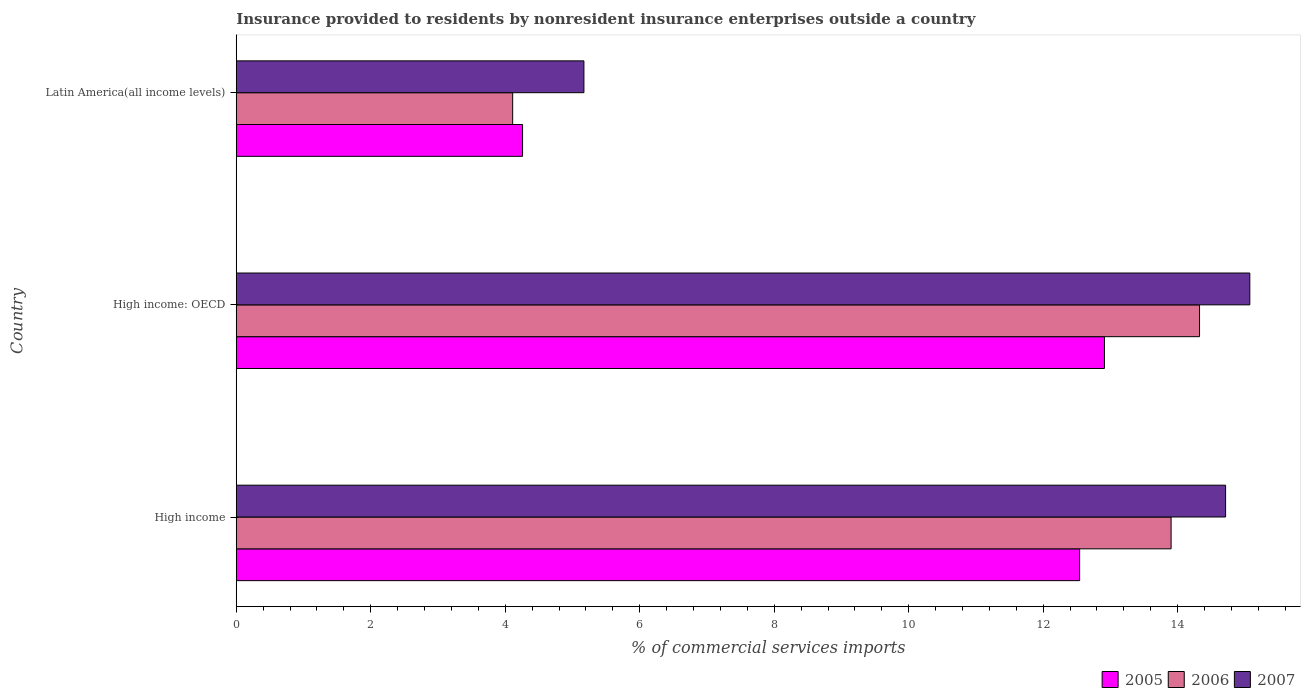How many different coloured bars are there?
Offer a very short reply. 3. How many groups of bars are there?
Your answer should be compact. 3. Are the number of bars on each tick of the Y-axis equal?
Keep it short and to the point. Yes. How many bars are there on the 2nd tick from the bottom?
Your answer should be very brief. 3. What is the label of the 2nd group of bars from the top?
Keep it short and to the point. High income: OECD. In how many cases, is the number of bars for a given country not equal to the number of legend labels?
Provide a succinct answer. 0. What is the Insurance provided to residents in 2006 in Latin America(all income levels)?
Your response must be concise. 4.11. Across all countries, what is the maximum Insurance provided to residents in 2006?
Provide a short and direct response. 14.33. Across all countries, what is the minimum Insurance provided to residents in 2005?
Your response must be concise. 4.26. In which country was the Insurance provided to residents in 2007 maximum?
Provide a succinct answer. High income: OECD. In which country was the Insurance provided to residents in 2005 minimum?
Make the answer very short. Latin America(all income levels). What is the total Insurance provided to residents in 2005 in the graph?
Your answer should be compact. 29.71. What is the difference between the Insurance provided to residents in 2006 in High income and that in High income: OECD?
Keep it short and to the point. -0.42. What is the difference between the Insurance provided to residents in 2006 in High income and the Insurance provided to residents in 2005 in Latin America(all income levels)?
Offer a terse response. 9.64. What is the average Insurance provided to residents in 2007 per country?
Your answer should be very brief. 11.65. What is the difference between the Insurance provided to residents in 2006 and Insurance provided to residents in 2007 in High income: OECD?
Make the answer very short. -0.75. What is the ratio of the Insurance provided to residents in 2006 in High income to that in High income: OECD?
Offer a terse response. 0.97. Is the Insurance provided to residents in 2007 in High income less than that in Latin America(all income levels)?
Keep it short and to the point. No. Is the difference between the Insurance provided to residents in 2006 in High income and High income: OECD greater than the difference between the Insurance provided to residents in 2007 in High income and High income: OECD?
Keep it short and to the point. No. What is the difference between the highest and the second highest Insurance provided to residents in 2006?
Your response must be concise. 0.42. What is the difference between the highest and the lowest Insurance provided to residents in 2006?
Give a very brief answer. 10.21. Is the sum of the Insurance provided to residents in 2006 in High income and Latin America(all income levels) greater than the maximum Insurance provided to residents in 2005 across all countries?
Your answer should be very brief. Yes. How many bars are there?
Your answer should be very brief. 9. What is the title of the graph?
Provide a short and direct response. Insurance provided to residents by nonresident insurance enterprises outside a country. Does "1986" appear as one of the legend labels in the graph?
Provide a succinct answer. No. What is the label or title of the X-axis?
Offer a very short reply. % of commercial services imports. What is the % of commercial services imports in 2005 in High income?
Provide a short and direct response. 12.54. What is the % of commercial services imports of 2006 in High income?
Your answer should be very brief. 13.9. What is the % of commercial services imports of 2007 in High income?
Give a very brief answer. 14.71. What is the % of commercial services imports of 2005 in High income: OECD?
Give a very brief answer. 12.91. What is the % of commercial services imports in 2006 in High income: OECD?
Offer a terse response. 14.33. What is the % of commercial services imports of 2007 in High income: OECD?
Offer a very short reply. 15.07. What is the % of commercial services imports in 2005 in Latin America(all income levels)?
Give a very brief answer. 4.26. What is the % of commercial services imports in 2006 in Latin America(all income levels)?
Offer a terse response. 4.11. What is the % of commercial services imports of 2007 in Latin America(all income levels)?
Provide a succinct answer. 5.17. Across all countries, what is the maximum % of commercial services imports of 2005?
Your response must be concise. 12.91. Across all countries, what is the maximum % of commercial services imports in 2006?
Give a very brief answer. 14.33. Across all countries, what is the maximum % of commercial services imports in 2007?
Give a very brief answer. 15.07. Across all countries, what is the minimum % of commercial services imports of 2005?
Your answer should be compact. 4.26. Across all countries, what is the minimum % of commercial services imports of 2006?
Keep it short and to the point. 4.11. Across all countries, what is the minimum % of commercial services imports in 2007?
Make the answer very short. 5.17. What is the total % of commercial services imports in 2005 in the graph?
Ensure brevity in your answer.  29.71. What is the total % of commercial services imports of 2006 in the graph?
Make the answer very short. 32.34. What is the total % of commercial services imports of 2007 in the graph?
Keep it short and to the point. 34.96. What is the difference between the % of commercial services imports in 2005 in High income and that in High income: OECD?
Offer a very short reply. -0.37. What is the difference between the % of commercial services imports in 2006 in High income and that in High income: OECD?
Offer a terse response. -0.42. What is the difference between the % of commercial services imports in 2007 in High income and that in High income: OECD?
Provide a short and direct response. -0.36. What is the difference between the % of commercial services imports in 2005 in High income and that in Latin America(all income levels)?
Give a very brief answer. 8.28. What is the difference between the % of commercial services imports in 2006 in High income and that in Latin America(all income levels)?
Your response must be concise. 9.79. What is the difference between the % of commercial services imports of 2007 in High income and that in Latin America(all income levels)?
Offer a terse response. 9.54. What is the difference between the % of commercial services imports in 2005 in High income: OECD and that in Latin America(all income levels)?
Provide a short and direct response. 8.65. What is the difference between the % of commercial services imports of 2006 in High income: OECD and that in Latin America(all income levels)?
Ensure brevity in your answer.  10.21. What is the difference between the % of commercial services imports in 2007 in High income: OECD and that in Latin America(all income levels)?
Keep it short and to the point. 9.9. What is the difference between the % of commercial services imports in 2005 in High income and the % of commercial services imports in 2006 in High income: OECD?
Keep it short and to the point. -1.78. What is the difference between the % of commercial services imports in 2005 in High income and the % of commercial services imports in 2007 in High income: OECD?
Ensure brevity in your answer.  -2.53. What is the difference between the % of commercial services imports of 2006 in High income and the % of commercial services imports of 2007 in High income: OECD?
Make the answer very short. -1.17. What is the difference between the % of commercial services imports of 2005 in High income and the % of commercial services imports of 2006 in Latin America(all income levels)?
Ensure brevity in your answer.  8.43. What is the difference between the % of commercial services imports of 2005 in High income and the % of commercial services imports of 2007 in Latin America(all income levels)?
Provide a short and direct response. 7.37. What is the difference between the % of commercial services imports in 2006 in High income and the % of commercial services imports in 2007 in Latin America(all income levels)?
Give a very brief answer. 8.73. What is the difference between the % of commercial services imports in 2005 in High income: OECD and the % of commercial services imports in 2006 in Latin America(all income levels)?
Keep it short and to the point. 8.8. What is the difference between the % of commercial services imports in 2005 in High income: OECD and the % of commercial services imports in 2007 in Latin America(all income levels)?
Give a very brief answer. 7.74. What is the difference between the % of commercial services imports of 2006 in High income: OECD and the % of commercial services imports of 2007 in Latin America(all income levels)?
Your answer should be compact. 9.15. What is the average % of commercial services imports in 2005 per country?
Your answer should be compact. 9.9. What is the average % of commercial services imports of 2006 per country?
Your response must be concise. 10.78. What is the average % of commercial services imports in 2007 per country?
Provide a short and direct response. 11.65. What is the difference between the % of commercial services imports of 2005 and % of commercial services imports of 2006 in High income?
Provide a short and direct response. -1.36. What is the difference between the % of commercial services imports in 2005 and % of commercial services imports in 2007 in High income?
Your answer should be very brief. -2.17. What is the difference between the % of commercial services imports in 2006 and % of commercial services imports in 2007 in High income?
Provide a succinct answer. -0.81. What is the difference between the % of commercial services imports in 2005 and % of commercial services imports in 2006 in High income: OECD?
Offer a terse response. -1.41. What is the difference between the % of commercial services imports of 2005 and % of commercial services imports of 2007 in High income: OECD?
Ensure brevity in your answer.  -2.16. What is the difference between the % of commercial services imports in 2006 and % of commercial services imports in 2007 in High income: OECD?
Provide a short and direct response. -0.75. What is the difference between the % of commercial services imports of 2005 and % of commercial services imports of 2006 in Latin America(all income levels)?
Your response must be concise. 0.15. What is the difference between the % of commercial services imports in 2005 and % of commercial services imports in 2007 in Latin America(all income levels)?
Keep it short and to the point. -0.91. What is the difference between the % of commercial services imports in 2006 and % of commercial services imports in 2007 in Latin America(all income levels)?
Offer a very short reply. -1.06. What is the ratio of the % of commercial services imports of 2005 in High income to that in High income: OECD?
Provide a short and direct response. 0.97. What is the ratio of the % of commercial services imports of 2006 in High income to that in High income: OECD?
Your response must be concise. 0.97. What is the ratio of the % of commercial services imports in 2007 in High income to that in High income: OECD?
Keep it short and to the point. 0.98. What is the ratio of the % of commercial services imports in 2005 in High income to that in Latin America(all income levels)?
Offer a terse response. 2.95. What is the ratio of the % of commercial services imports in 2006 in High income to that in Latin America(all income levels)?
Your answer should be very brief. 3.38. What is the ratio of the % of commercial services imports of 2007 in High income to that in Latin America(all income levels)?
Give a very brief answer. 2.85. What is the ratio of the % of commercial services imports in 2005 in High income: OECD to that in Latin America(all income levels)?
Provide a succinct answer. 3.03. What is the ratio of the % of commercial services imports in 2006 in High income: OECD to that in Latin America(all income levels)?
Provide a short and direct response. 3.48. What is the ratio of the % of commercial services imports in 2007 in High income: OECD to that in Latin America(all income levels)?
Your answer should be compact. 2.92. What is the difference between the highest and the second highest % of commercial services imports of 2005?
Provide a short and direct response. 0.37. What is the difference between the highest and the second highest % of commercial services imports in 2006?
Give a very brief answer. 0.42. What is the difference between the highest and the second highest % of commercial services imports of 2007?
Provide a short and direct response. 0.36. What is the difference between the highest and the lowest % of commercial services imports in 2005?
Provide a succinct answer. 8.65. What is the difference between the highest and the lowest % of commercial services imports of 2006?
Make the answer very short. 10.21. What is the difference between the highest and the lowest % of commercial services imports of 2007?
Provide a short and direct response. 9.9. 